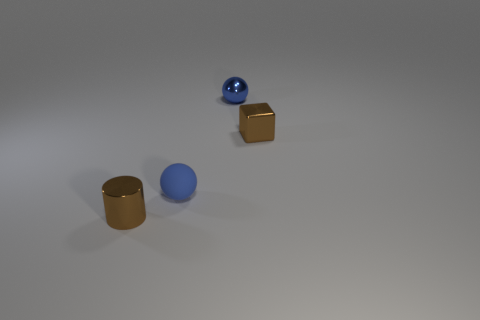Add 4 brown metallic cubes. How many objects exist? 8 Subtract all cubes. How many objects are left? 3 Subtract all tiny matte balls. Subtract all tiny blue metal spheres. How many objects are left? 2 Add 2 small brown cylinders. How many small brown cylinders are left? 3 Add 1 big cyan metal spheres. How many big cyan metal spheres exist? 1 Subtract 0 purple cubes. How many objects are left? 4 